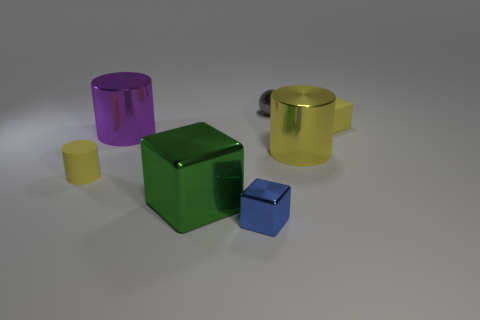Is the number of shiny cylinders right of the green metallic block greater than the number of matte cylinders to the left of the large purple shiny cylinder?
Keep it short and to the point. No. There is a purple object that is the same size as the yellow metal cylinder; what is its material?
Make the answer very short. Metal. The big yellow object has what shape?
Your response must be concise. Cylinder. How many green objects are either metallic cubes or metal spheres?
Your response must be concise. 1. The other block that is made of the same material as the green cube is what size?
Ensure brevity in your answer.  Small. Is the cube on the right side of the gray shiny sphere made of the same material as the tiny yellow cylinder that is to the left of the blue metal cube?
Offer a very short reply. Yes. How many balls are small green matte objects or tiny gray things?
Give a very brief answer. 1. There is a small yellow rubber thing to the right of the yellow rubber object in front of the big purple cylinder; how many purple metal objects are in front of it?
Ensure brevity in your answer.  1. There is another large thing that is the same shape as the purple shiny object; what material is it?
Offer a very short reply. Metal. Are there any other things that have the same material as the small yellow cylinder?
Ensure brevity in your answer.  Yes. 